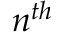<formula> <loc_0><loc_0><loc_500><loc_500>n ^ { t h }</formula> 